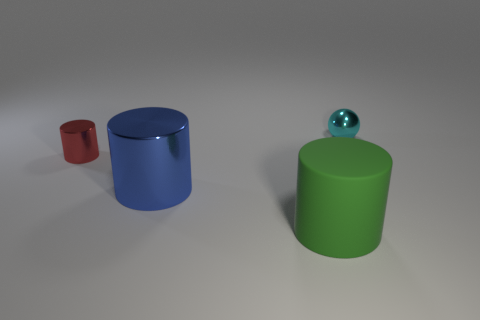The cyan shiny thing has what shape?
Provide a short and direct response. Sphere. What is the thing that is to the right of the small red cylinder and to the left of the green object made of?
Offer a very short reply. Metal. There is another tiny object that is made of the same material as the tiny cyan thing; what is its shape?
Make the answer very short. Cylinder. What size is the blue thing that is the same material as the tiny cylinder?
Ensure brevity in your answer.  Large. What shape is the object that is behind the green matte cylinder and to the right of the large blue thing?
Give a very brief answer. Sphere. There is a shiny object that is in front of the small metallic thing on the left side of the tiny metal ball; what size is it?
Provide a succinct answer. Large. What number of other objects are there of the same color as the ball?
Your answer should be compact. 0. What is the material of the big green object?
Your response must be concise. Rubber. Are any green matte things visible?
Provide a short and direct response. Yes. Are there the same number of cyan shiny balls to the right of the cyan shiny ball and cyan rubber spheres?
Offer a terse response. Yes. 